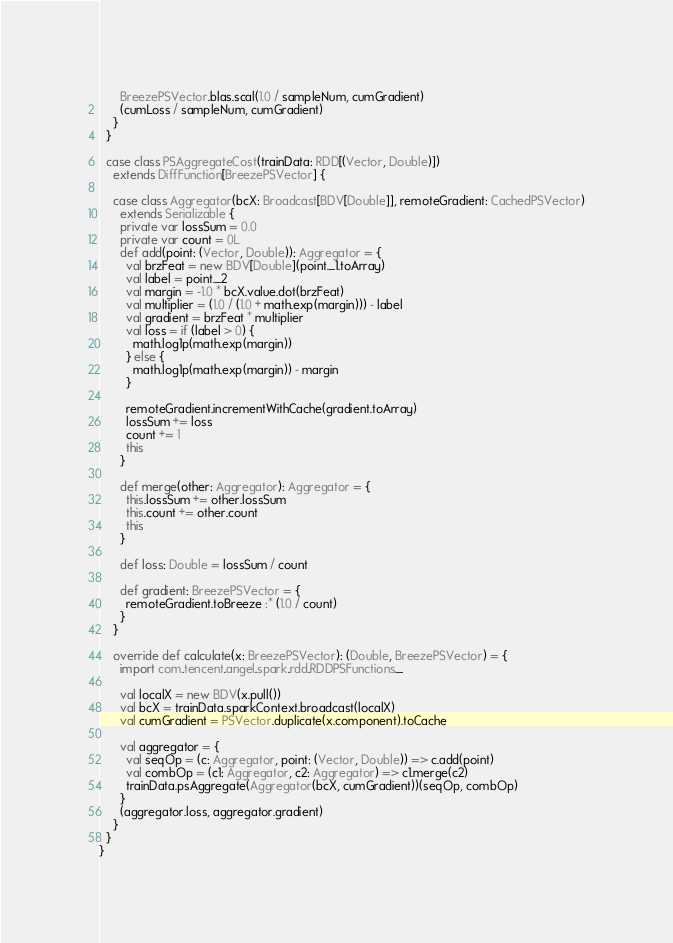<code> <loc_0><loc_0><loc_500><loc_500><_Scala_>      BreezePSVector.blas.scal(1.0 / sampleNum, cumGradient)
      (cumLoss / sampleNum, cumGradient)
    }
  }

  case class PSAggregateCost(trainData: RDD[(Vector, Double)])
    extends DiffFunction[BreezePSVector] {

    case class Aggregator(bcX: Broadcast[BDV[Double]], remoteGradient: CachedPSVector)
      extends Serializable {
      private var lossSum = 0.0
      private var count = 0L
      def add(point: (Vector, Double)): Aggregator = {
        val brzFeat = new BDV[Double](point._1.toArray)
        val label = point._2
        val margin = -1.0 * bcX.value.dot(brzFeat)
        val multiplier = (1.0 / (1.0 + math.exp(margin))) - label
        val gradient = brzFeat * multiplier
        val loss = if (label > 0) {
          math.log1p(math.exp(margin))
        } else {
          math.log1p(math.exp(margin)) - margin
        }

        remoteGradient.incrementWithCache(gradient.toArray)
        lossSum += loss
        count += 1
        this
      }

      def merge(other: Aggregator): Aggregator = {
        this.lossSum += other.lossSum
        this.count += other.count
        this
      }

      def loss: Double = lossSum / count

      def gradient: BreezePSVector = {
        remoteGradient.toBreeze :* (1.0 / count)
      }
    }

    override def calculate(x: BreezePSVector): (Double, BreezePSVector) = {
      import com.tencent.angel.spark.rdd.RDDPSFunctions._

      val localX = new BDV(x.pull())
      val bcX = trainData.sparkContext.broadcast(localX)
      val cumGradient = PSVector.duplicate(x.component).toCache

      val aggregator = {
        val seqOp = (c: Aggregator, point: (Vector, Double)) => c.add(point)
        val combOp = (c1: Aggregator, c2: Aggregator) => c1.merge(c2)
        trainData.psAggregate(Aggregator(bcX, cumGradient))(seqOp, combOp)
      }
      (aggregator.loss, aggregator.gradient)
    }
  }
}
</code> 